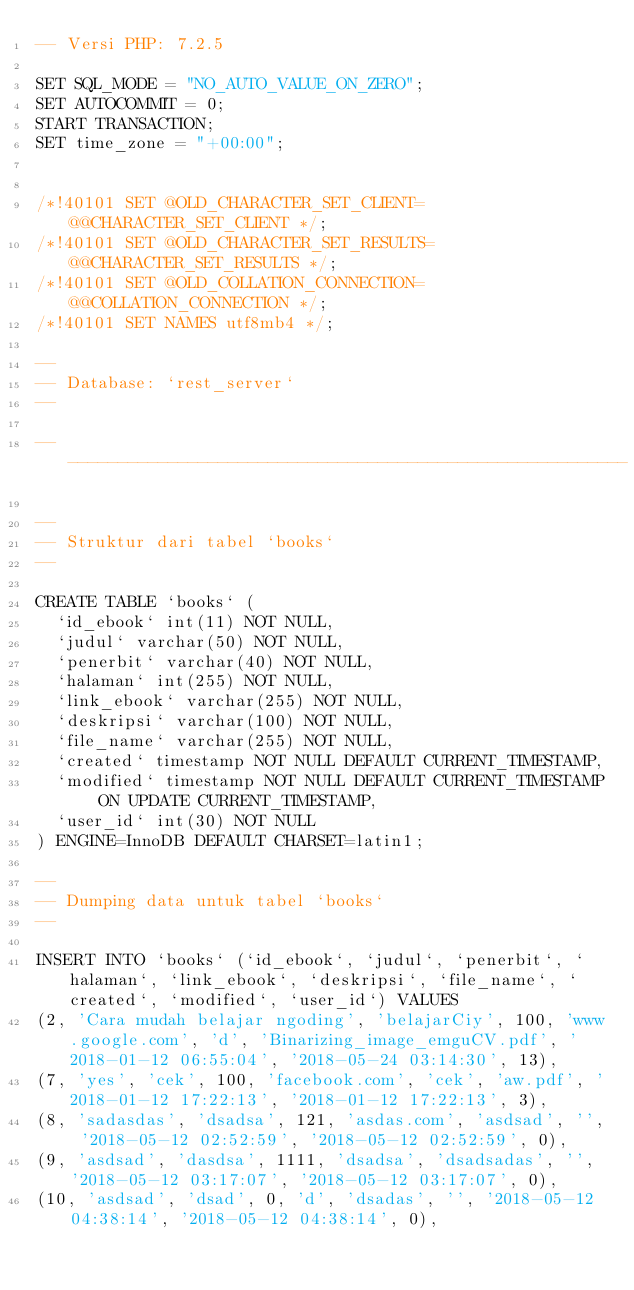Convert code to text. <code><loc_0><loc_0><loc_500><loc_500><_SQL_>-- Versi PHP: 7.2.5

SET SQL_MODE = "NO_AUTO_VALUE_ON_ZERO";
SET AUTOCOMMIT = 0;
START TRANSACTION;
SET time_zone = "+00:00";


/*!40101 SET @OLD_CHARACTER_SET_CLIENT=@@CHARACTER_SET_CLIENT */;
/*!40101 SET @OLD_CHARACTER_SET_RESULTS=@@CHARACTER_SET_RESULTS */;
/*!40101 SET @OLD_COLLATION_CONNECTION=@@COLLATION_CONNECTION */;
/*!40101 SET NAMES utf8mb4 */;

--
-- Database: `rest_server`
--

-- --------------------------------------------------------

--
-- Struktur dari tabel `books`
--

CREATE TABLE `books` (
  `id_ebook` int(11) NOT NULL,
  `judul` varchar(50) NOT NULL,
  `penerbit` varchar(40) NOT NULL,
  `halaman` int(255) NOT NULL,
  `link_ebook` varchar(255) NOT NULL,
  `deskripsi` varchar(100) NOT NULL,
  `file_name` varchar(255) NOT NULL,
  `created` timestamp NOT NULL DEFAULT CURRENT_TIMESTAMP,
  `modified` timestamp NOT NULL DEFAULT CURRENT_TIMESTAMP ON UPDATE CURRENT_TIMESTAMP,
  `user_id` int(30) NOT NULL
) ENGINE=InnoDB DEFAULT CHARSET=latin1;

--
-- Dumping data untuk tabel `books`
--

INSERT INTO `books` (`id_ebook`, `judul`, `penerbit`, `halaman`, `link_ebook`, `deskripsi`, `file_name`, `created`, `modified`, `user_id`) VALUES
(2, 'Cara mudah belajar ngoding', 'belajarCiy', 100, 'www.google.com', 'd', 'Binarizing_image_emguCV.pdf', '2018-01-12 06:55:04', '2018-05-24 03:14:30', 13),
(7, 'yes', 'cek', 100, 'facebook.com', 'cek', 'aw.pdf', '2018-01-12 17:22:13', '2018-01-12 17:22:13', 3),
(8, 'sadasdas', 'dsadsa', 121, 'asdas.com', 'asdsad', '', '2018-05-12 02:52:59', '2018-05-12 02:52:59', 0),
(9, 'asdsad', 'dasdsa', 1111, 'dsadsa', 'dsadsadas', '', '2018-05-12 03:17:07', '2018-05-12 03:17:07', 0),
(10, 'asdsad', 'dsad', 0, 'd', 'dsadas', '', '2018-05-12 04:38:14', '2018-05-12 04:38:14', 0),</code> 